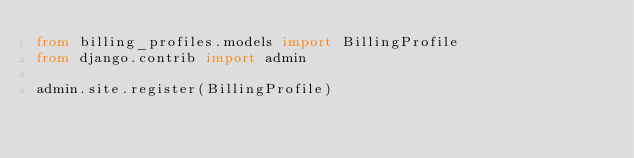Convert code to text. <code><loc_0><loc_0><loc_500><loc_500><_Python_>from billing_profiles.models import BillingProfile
from django.contrib import admin

admin.site.register(BillingProfile)</code> 